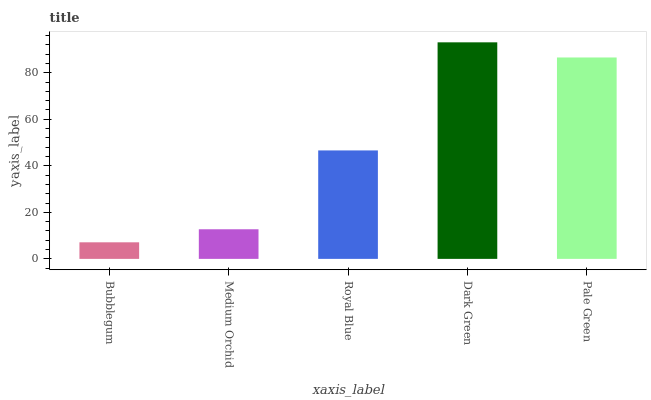Is Bubblegum the minimum?
Answer yes or no. Yes. Is Dark Green the maximum?
Answer yes or no. Yes. Is Medium Orchid the minimum?
Answer yes or no. No. Is Medium Orchid the maximum?
Answer yes or no. No. Is Medium Orchid greater than Bubblegum?
Answer yes or no. Yes. Is Bubblegum less than Medium Orchid?
Answer yes or no. Yes. Is Bubblegum greater than Medium Orchid?
Answer yes or no. No. Is Medium Orchid less than Bubblegum?
Answer yes or no. No. Is Royal Blue the high median?
Answer yes or no. Yes. Is Royal Blue the low median?
Answer yes or no. Yes. Is Bubblegum the high median?
Answer yes or no. No. Is Bubblegum the low median?
Answer yes or no. No. 